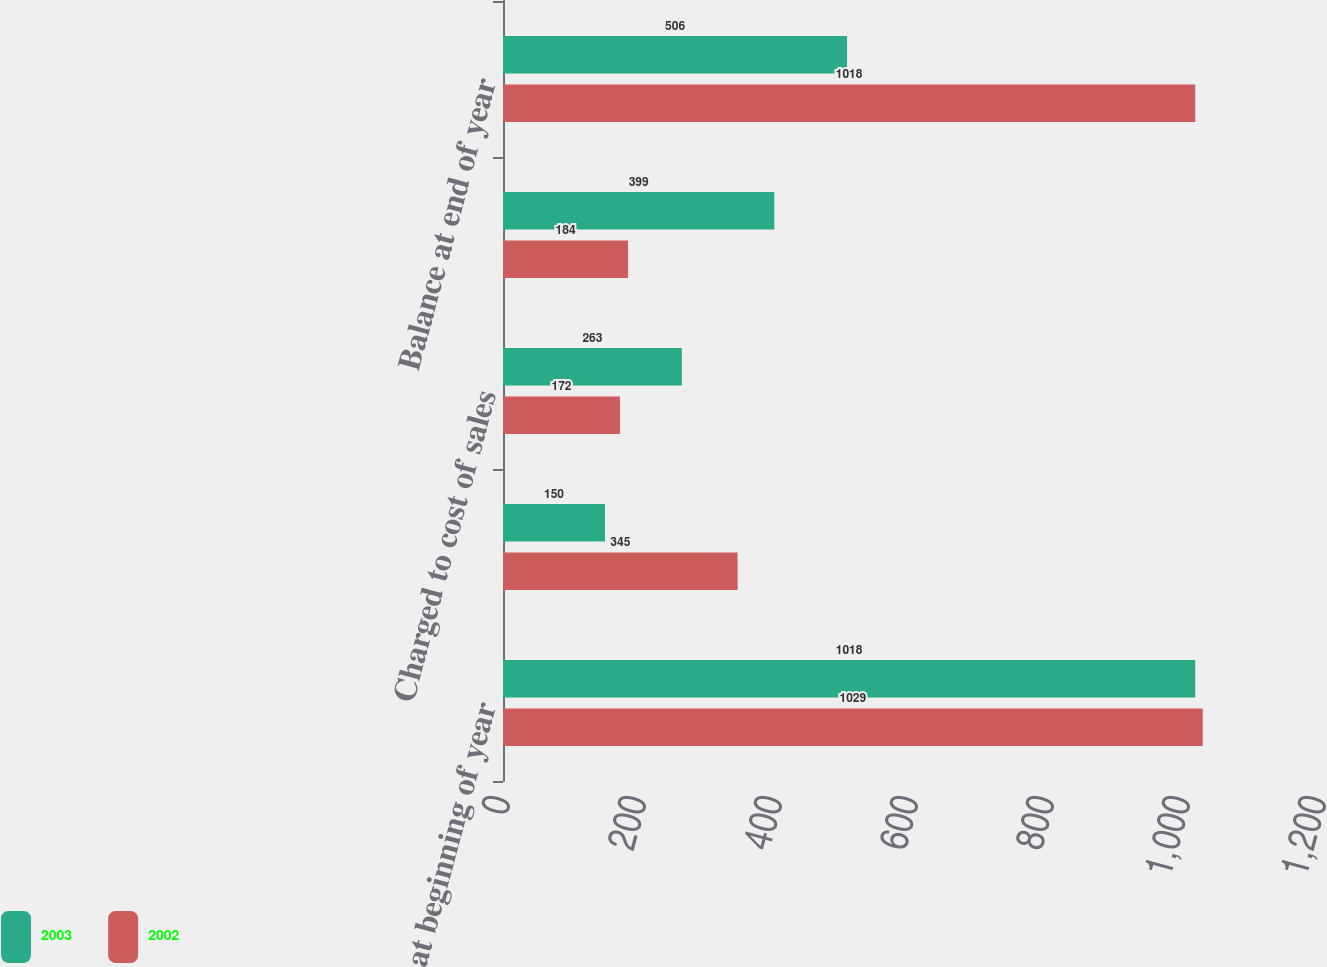Convert chart. <chart><loc_0><loc_0><loc_500><loc_500><stacked_bar_chart><ecel><fcel>Balance at beginning of year<fcel>Capitalized in year<fcel>Charged to cost of sales<fcel>Impairment charged to income<fcel>Balance at end of year<nl><fcel>2003<fcel>1018<fcel>150<fcel>263<fcel>399<fcel>506<nl><fcel>2002<fcel>1029<fcel>345<fcel>172<fcel>184<fcel>1018<nl></chart> 